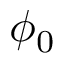<formula> <loc_0><loc_0><loc_500><loc_500>\phi _ { 0 }</formula> 